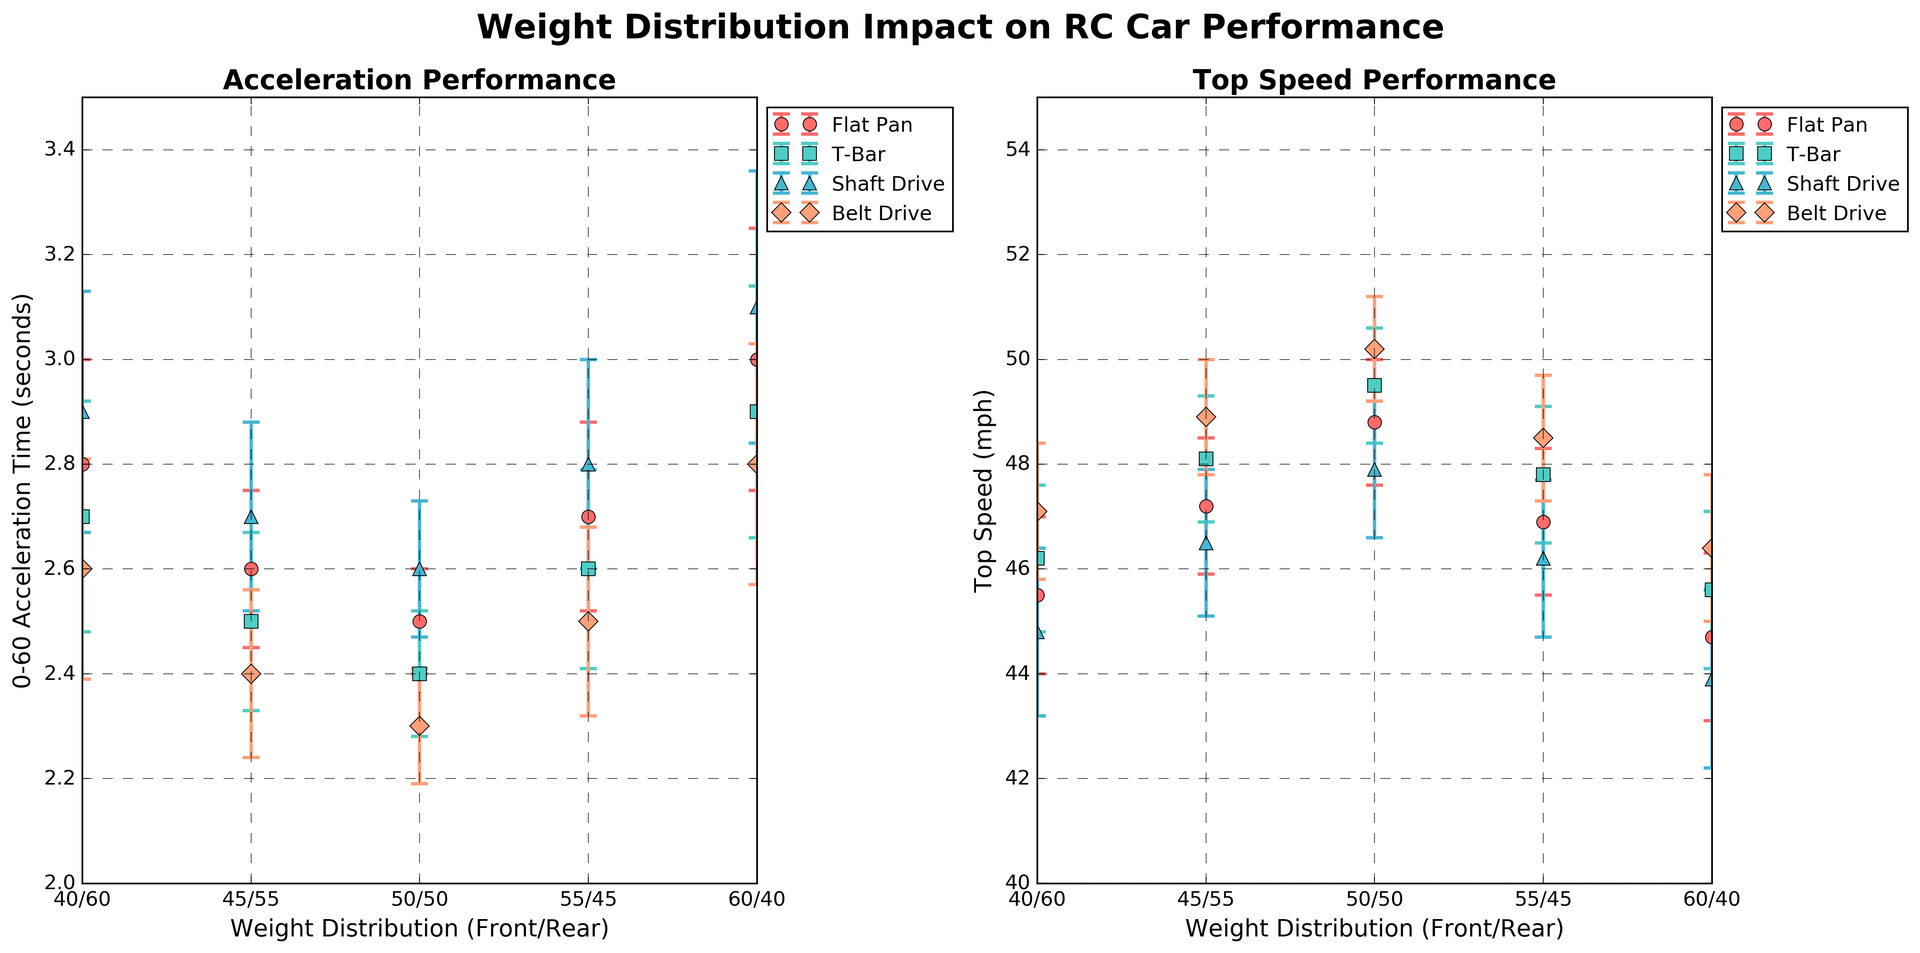What weight distribution in the Flat Pan chassis provides the best acceleration performance? By examining the 'Acceleration Performance' plot on the left, we note that the Flat Pan chassis with a 50/50 weight distribution achieves the lowest 0-60 acceleration time.
Answer: 50/50 How does the top speed performance of the T-Bar chassis compare between a 45/55 and a 50/50 weight distribution? Referring to the 'Top Speed Performance' plot on the right, the T-Bar chassis achieves a top speed of approximately 48.1 mph with a 45/55 weight distribution and 49.5 mph with a 50/50 weight distribution. Therefore, the 50/50 distribution is higher.
Answer: 50/50 has a higher top speed Which chassis type shows the greatest change in acceleration performance when shifting from a 60/40 to a 50/50 weight distribution? By comparing the points in the 'Acceleration Performance' plot, the Belt Drive chassis decreases from 2.8 to 2.3 seconds, which is a 0.5-second improvement—the greatest among all chassis types for this weight shift.
Answer: Belt Drive What is the average top speed of Shaft Drive chassis at all weight distributions? The top speeds for the Shaft Drive chassis are 44.8, 46.5, 47.9, 46.2, and 43.9 mph. Summing these values gives 229.3 mph. Dividing by 5 (number of data points) yields an average of approximately 45.86 mph.
Answer: 45.86 mph In the acceleration performance plot, which chassis type exhibits the least variability in acceleration? The error bars in the 'Acceleration Performance' plot indicate variability. By comparing these visually, the Belt Drive chassis has the smallest error bars on average, suggesting the least variability.
Answer: Belt Drive Compare the top speed performances of all chassis types at a 50/50 weight distribution. Which chassis type achieves the highest top speed? From the 'Top Speed Performance' plot, the top speeds at 50/50 are: Flat Pan (48.8 mph), T-Bar (49.5 mph), Shaft Drive (47.9 mph), and Belt Drive (50.2 mph). Belt Drive achieves the highest top speed.
Answer: Belt Drive Does the weight distribution leaning more towards the rear (60/40) generally have a better or worse top speed performance across all chassis types? Observing the 'Top Speed Performance' plot, at 60/40 distribution, all chassis types exhibit relatively lower top speeds, indicating that a rear-heavy distribution leads to worse top speed performance.
Answer: Worse Identify the chassis type with the smallest improvement in acceleration time from a 55/45 to 50/50 weight distribution. By referring to 'Acceleration Performance' plot, the improvements for each chassis type are: Flat Pan (0.2 sec), T-Bar (0.2 sec), Shaft Drive (0.2 sec), Belt Drive (0.2 sec). All chassis types show equal improvement in acceleration time.
Answer: All are equal How does the acceleration performance of the Shaft Drive chassis at 55/45 compare to the Belt Drive chassis at 40/60? From the 'Acceleration Performance' plot, the Shaft Drive with 55/45 distribution shows an acceleration time of 2.8 sec, while Belt Drive with 40/60 distribution shows 2.6 sec. The Belt Drive at 40/60 achieves better performance (lower time).
Answer: Belt Drive at 40/60 performs better Which chassis type and weight distribution combination yields the lowest acceleration time, and what is the associated top speed? By checking the 'Acceleration Performance' plot, the Belt Drive chassis with a 50/50 weight distribution achieves the lowest acceleration time of 2.3 seconds. Its top speed from the 'Top Speed Performance' plot is 50.2 mph.
Answer: Belt Drive at 50/50 yields lowest acceleration time at 50.2 mph 